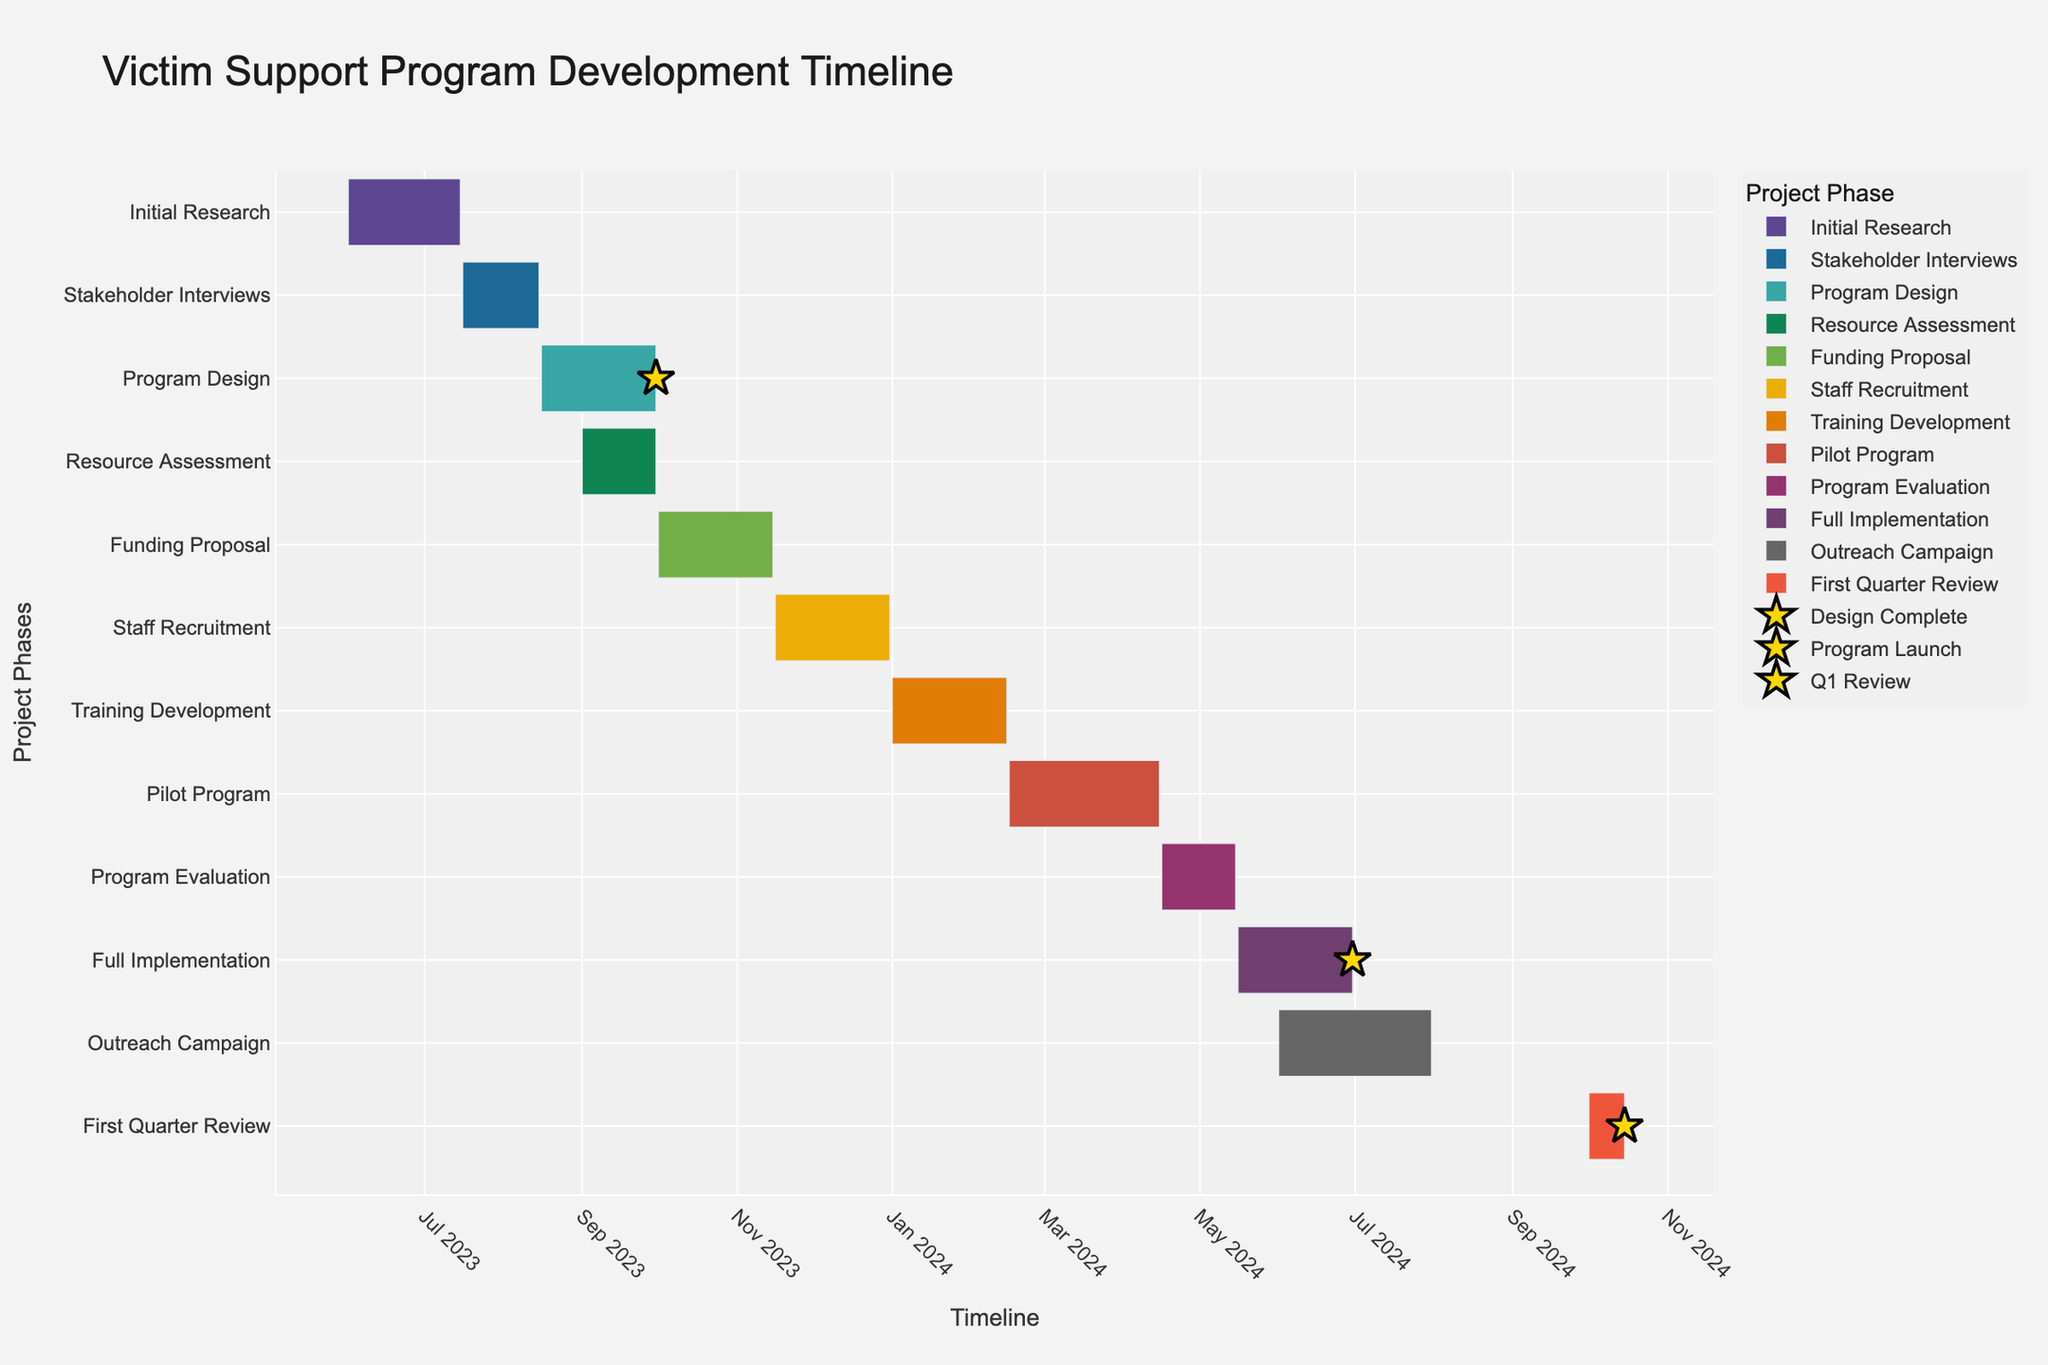What's the title of the Gantt Chart? The title is prominently displayed at the top of the chart, providing an overview of the chart's purpose.
Answer: Victim Support Program Development Timeline Which project phases run simultaneously in September 2023? By examining the timeline, we can see which tasks overlap during September 2023.
Answer: Program Design and Resource Assessment When does the "Pilot Program" phase start and end? Locate the "Pilot Program" on the y-axis and read the corresponding start and end dates from the timeline.
Answer: February 16, 2024, to April 15, 2024 What is the total duration of the "Initial Research" phase? Find the "Initial Research" phase on the chart and calculate the duration by subtracting the start date from the end date.
Answer: 45 days How does the duration of "Staff Recruitment" compare to "Training Development"? Identify the duration of both tasks and compare them to see which one is longer.
Answer: Staff Recruitment is longer What milestone is indicated at the end of the "Program Design" phase? Find the marker at the end of the "Program Design" phase and note the milestone name provided in the hover information or legend.
Answer: Design Complete How many tasks are scheduled for 2024? Count all the tasks on the y-axis that have start or end dates in 2024.
Answer: 7 tasks Which task ends first in 2024? Look at the tasks scheduled in 2024 and identify the one with the earliest end date.
Answer: Training Development What is the overlap period between "Full Implementation" and "Outreach Campaign"? Calculate the overlapping days between the start of "Outreach Campaign" and the end of "Full Implementation".
Answer: June 1, 2024, to June 30, 2024 When is the "First Quarter Review" scheduled? Look for the "First Quarter Review" phase on the y-axis and identify its start and end dates.
Answer: October 1, 2024, to October 15, 2024 